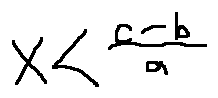<formula> <loc_0><loc_0><loc_500><loc_500>x < \frac { c - b } { a }</formula> 